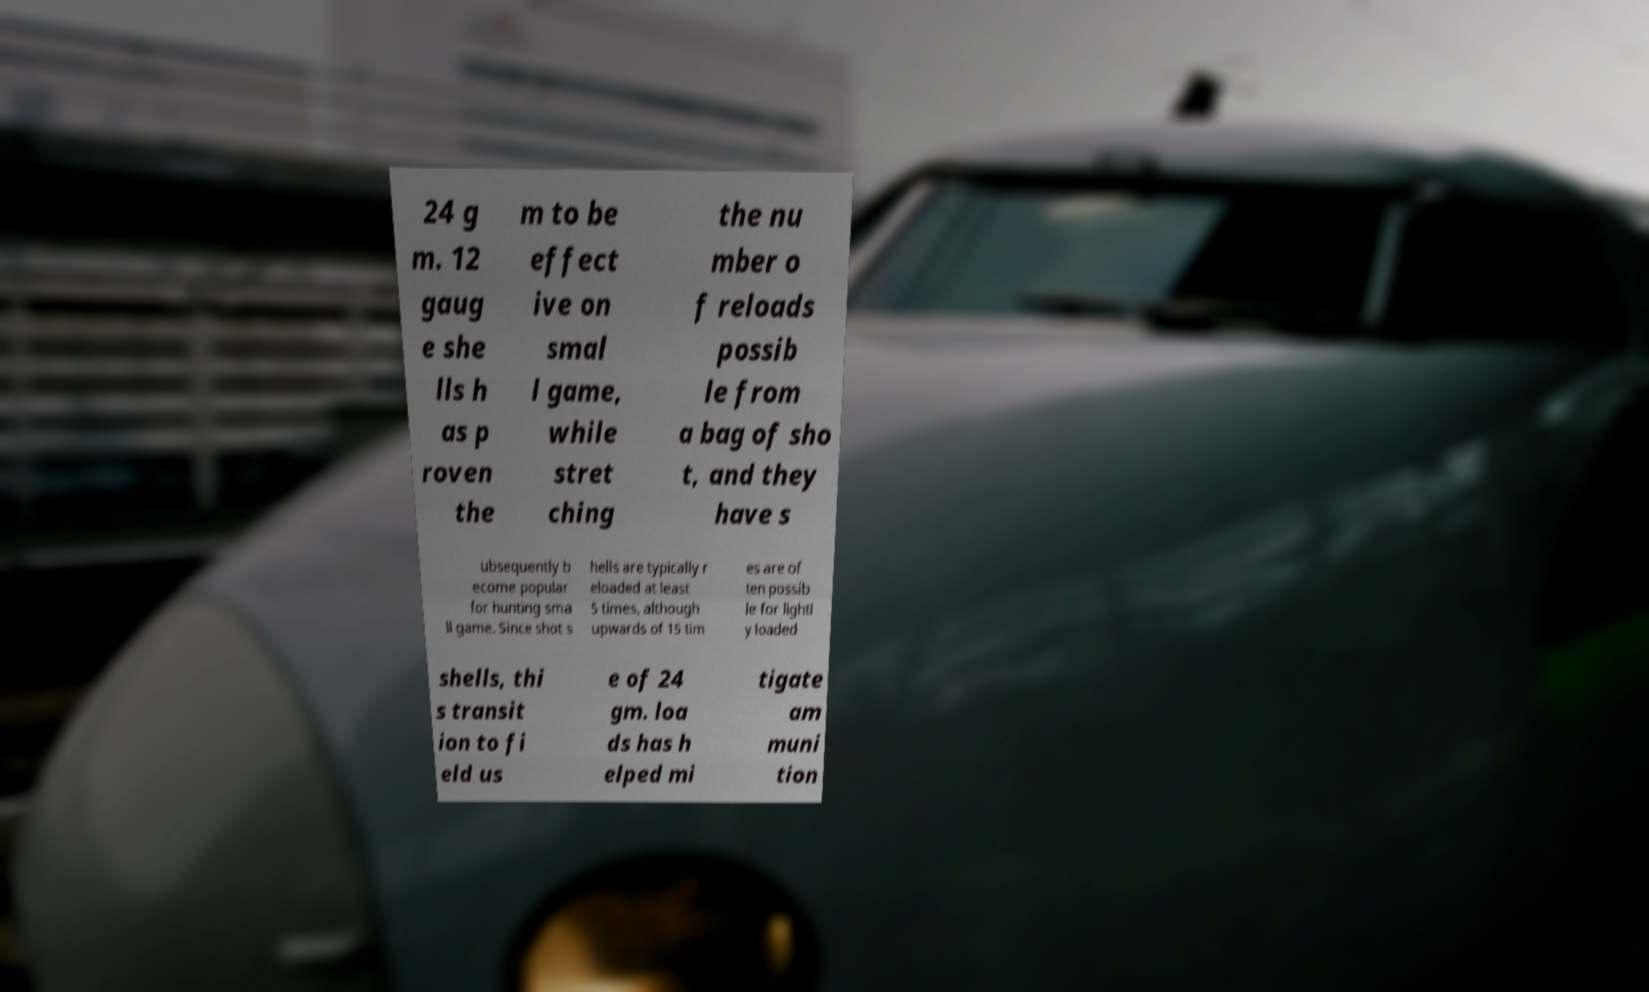Could you assist in decoding the text presented in this image and type it out clearly? 24 g m. 12 gaug e she lls h as p roven the m to be effect ive on smal l game, while stret ching the nu mber o f reloads possib le from a bag of sho t, and they have s ubsequently b ecome popular for hunting sma ll game. Since shot s hells are typically r eloaded at least 5 times, although upwards of 15 tim es are of ten possib le for lightl y loaded shells, thi s transit ion to fi eld us e of 24 gm. loa ds has h elped mi tigate am muni tion 